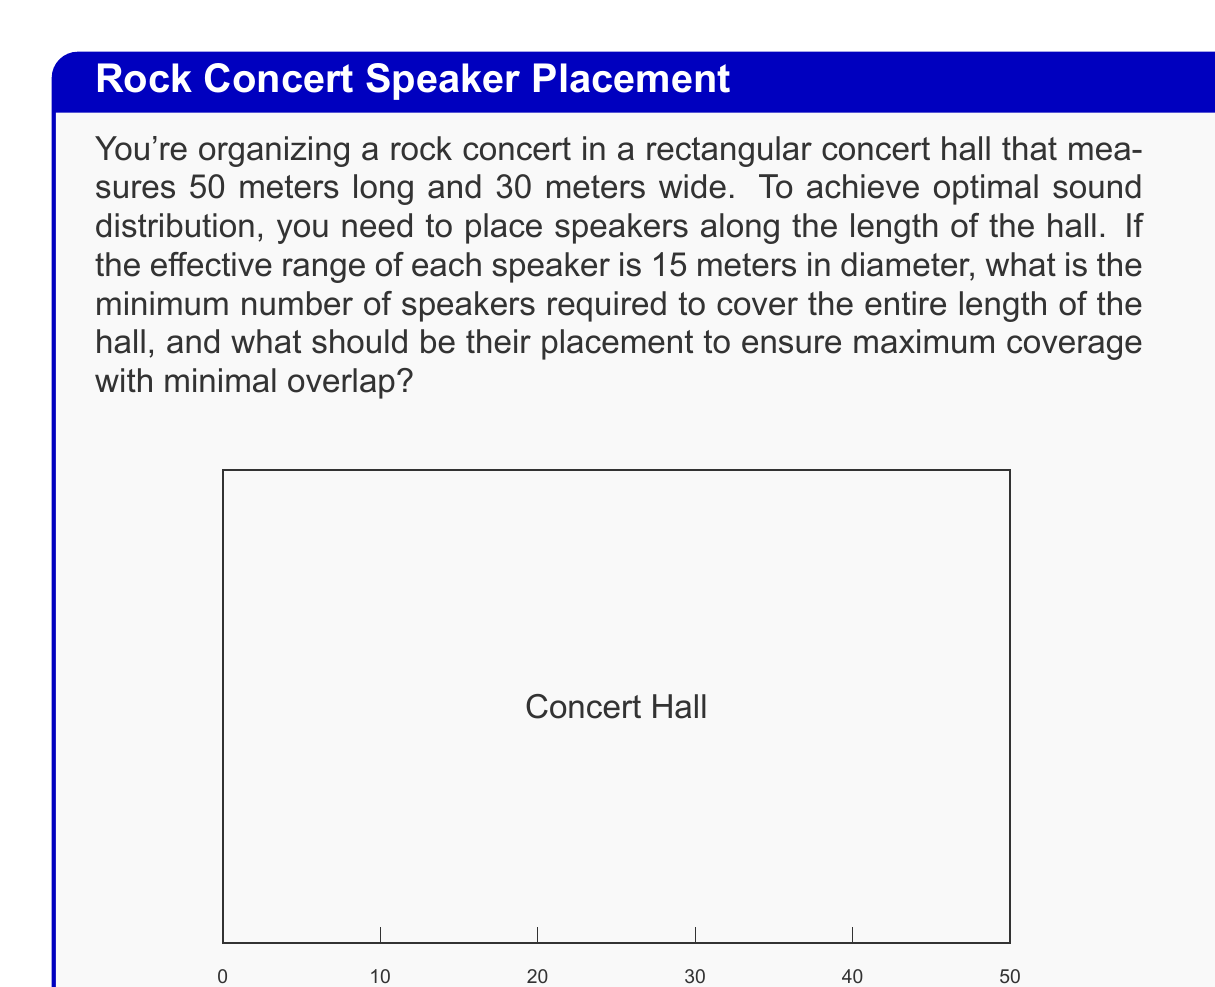What is the answer to this math problem? To solve this problem, we need to follow these steps:

1) First, we need to calculate how many speakers we can fit along the length of the hall with minimal overlap. We can do this by dividing the length of the hall by the diameter of each speaker's effective range.

   $$ \text{Number of speakers} = \left\lceil\frac{\text{Hall length}}{\text{Speaker range diameter}}\right\rceil $$

   $$ = \left\lceil\frac{50\text{ m}}{15\text{ m}}\right\rceil = \left\lceil3.33\right\rceil = 4 $$

   We round up to ensure full coverage.

2) Now that we know we need 4 speakers, we need to determine their optimal placement. To ensure even coverage, we should space them equally along the length of the hall.

3) To calculate the spacing, we divide the length of the hall by the number of speakers:

   $$ \text{Spacing} = \frac{\text{Hall length}}{\text{Number of speakers}} = \frac{50\text{ m}}{4} = 12.5\text{ m} $$

4) To minimize overlap and ensure coverage at the ends of the hall, we should place the first and last speakers half this distance from the ends. The placement of each speaker from the start of the hall can be calculated as:

   $$ \text{Position}_n = (n - 0.5) \times 12.5\text{ m} $$

   Where $n$ is the speaker number (1 to 4).

5) Therefore, the positions of the speakers from the start of the hall are:
   - Speaker 1: $(1 - 0.5) \times 12.5\text{ m} = 6.25\text{ m}$
   - Speaker 2: $(2 - 0.5) \times 12.5\text{ m} = 18.75\text{ m}$
   - Speaker 3: $(3 - 0.5) \times 12.5\text{ m} = 31.25\text{ m}$
   - Speaker 4: $(4 - 0.5) \times 12.5\text{ m} = 43.75\text{ m}$

This arrangement ensures maximum coverage with minimal overlap.
Answer: The minimum number of speakers required is 4, placed at 6.25 m, 18.75 m, 31.25 m, and 43.75 m from the start of the hall. 